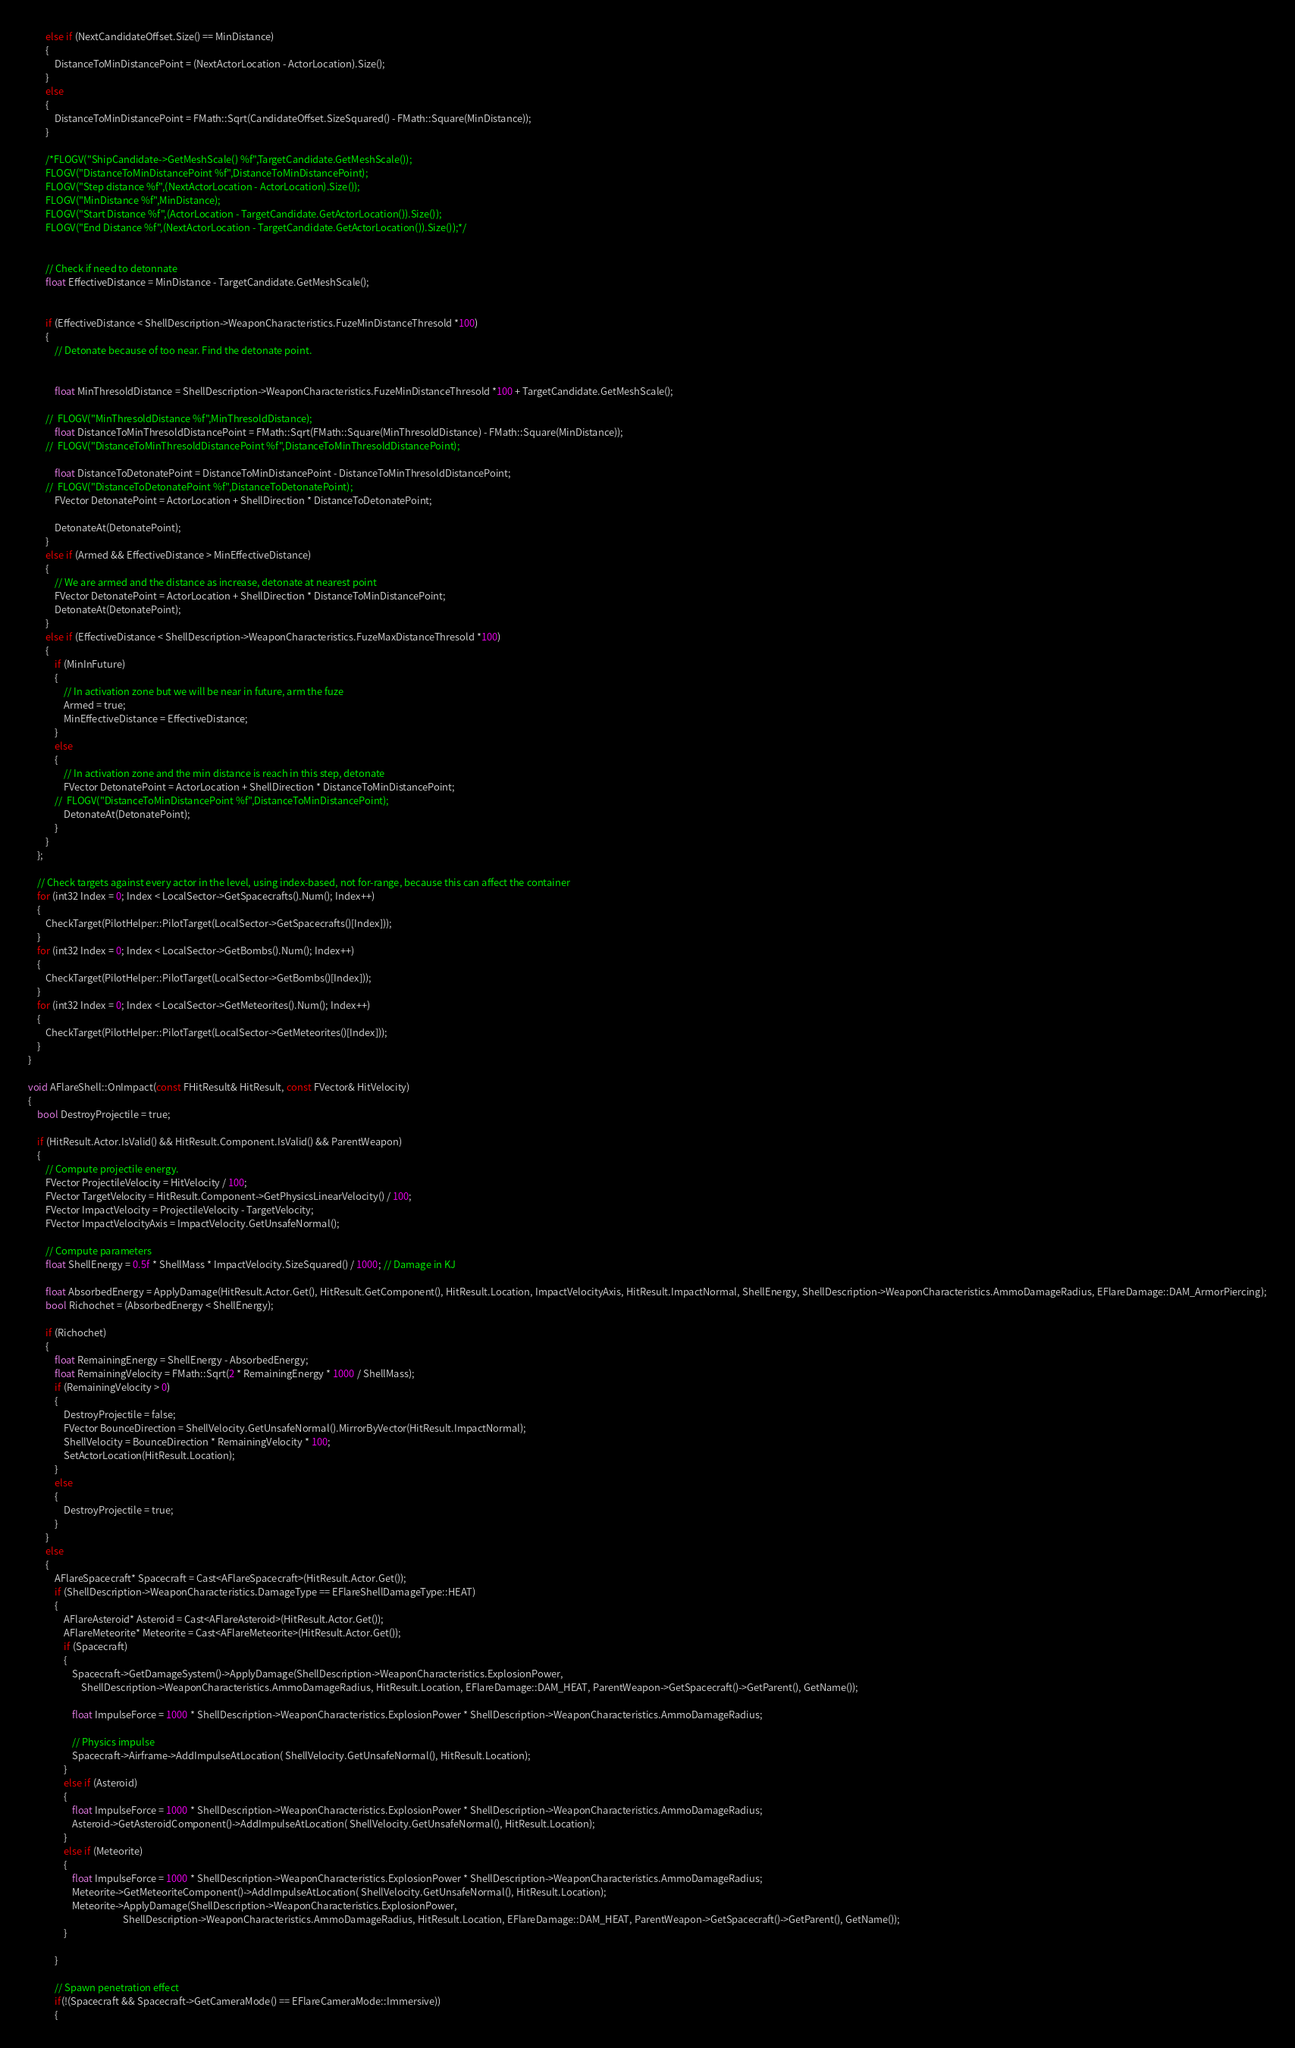Convert code to text. <code><loc_0><loc_0><loc_500><loc_500><_C++_>		else if (NextCandidateOffset.Size() == MinDistance)
		{
			DistanceToMinDistancePoint = (NextActorLocation - ActorLocation).Size();
		}
		else
		{
			DistanceToMinDistancePoint = FMath::Sqrt(CandidateOffset.SizeSquared() - FMath::Square(MinDistance));
		}

		/*FLOGV("ShipCandidate->GetMeshScale() %f",TargetCandidate.GetMeshScale());
		FLOGV("DistanceToMinDistancePoint %f",DistanceToMinDistancePoint);
		FLOGV("Step distance %f",(NextActorLocation - ActorLocation).Size());
		FLOGV("MinDistance %f",MinDistance);
		FLOGV("Start Distance %f",(ActorLocation - TargetCandidate.GetActorLocation()).Size());
		FLOGV("End Distance %f",(NextActorLocation - TargetCandidate.GetActorLocation()).Size());*/


		// Check if need to detonnate
		float EffectiveDistance = MinDistance - TargetCandidate.GetMeshScale();


		if (EffectiveDistance < ShellDescription->WeaponCharacteristics.FuzeMinDistanceThresold *100)
		{
			// Detonate because of too near. Find the detonate point.


			float MinThresoldDistance = ShellDescription->WeaponCharacteristics.FuzeMinDistanceThresold *100 + TargetCandidate.GetMeshScale();

		// 	FLOGV("MinThresoldDistance %f",MinThresoldDistance);
			float DistanceToMinThresoldDistancePoint = FMath::Sqrt(FMath::Square(MinThresoldDistance) - FMath::Square(MinDistance));
		// 	FLOGV("DistanceToMinThresoldDistancePoint %f",DistanceToMinThresoldDistancePoint);

			float DistanceToDetonatePoint = DistanceToMinDistancePoint - DistanceToMinThresoldDistancePoint;
		// 	FLOGV("DistanceToDetonatePoint %f",DistanceToDetonatePoint);
			FVector DetonatePoint = ActorLocation + ShellDirection * DistanceToDetonatePoint;

			DetonateAt(DetonatePoint);
		}
		else if (Armed && EffectiveDistance > MinEffectiveDistance)
		{
			// We are armed and the distance as increase, detonate at nearest point
			FVector DetonatePoint = ActorLocation + ShellDirection * DistanceToMinDistancePoint;
			DetonateAt(DetonatePoint);
		}
		else if (EffectiveDistance < ShellDescription->WeaponCharacteristics.FuzeMaxDistanceThresold *100)
		{
			if (MinInFuture)
			{
				// In activation zone but we will be near in future, arm the fuze
				Armed = true;
				MinEffectiveDistance = EffectiveDistance;
			}
			else
			{
				// In activation zone and the min distance is reach in this step, detonate
				FVector DetonatePoint = ActorLocation + ShellDirection * DistanceToMinDistancePoint;
			// 	FLOGV("DistanceToMinDistancePoint %f",DistanceToMinDistancePoint);
				DetonateAt(DetonatePoint);
			}
		}
	};

	// Check targets against every actor in the level, using index-based, not for-range, because this can affect the container
	for (int32 Index = 0; Index < LocalSector->GetSpacecrafts().Num(); Index++)
	{
		CheckTarget(PilotHelper::PilotTarget(LocalSector->GetSpacecrafts()[Index]));
	}
	for (int32 Index = 0; Index < LocalSector->GetBombs().Num(); Index++)
	{
		CheckTarget(PilotHelper::PilotTarget(LocalSector->GetBombs()[Index]));
	}
	for (int32 Index = 0; Index < LocalSector->GetMeteorites().Num(); Index++)
	{
		CheckTarget(PilotHelper::PilotTarget(LocalSector->GetMeteorites()[Index]));
	}
}

void AFlareShell::OnImpact(const FHitResult& HitResult, const FVector& HitVelocity)
{
	bool DestroyProjectile = true;
	
	if (HitResult.Actor.IsValid() && HitResult.Component.IsValid() && ParentWeapon)
	{
		// Compute projectile energy.
		FVector ProjectileVelocity = HitVelocity / 100;
		FVector TargetVelocity = HitResult.Component->GetPhysicsLinearVelocity() / 100;
		FVector ImpactVelocity = ProjectileVelocity - TargetVelocity;
		FVector ImpactVelocityAxis = ImpactVelocity.GetUnsafeNormal();
	
		// Compute parameters
		float ShellEnergy = 0.5f * ShellMass * ImpactVelocity.SizeSquared() / 1000; // Damage in KJ
		
		float AbsorbedEnergy = ApplyDamage(HitResult.Actor.Get(), HitResult.GetComponent(), HitResult.Location, ImpactVelocityAxis, HitResult.ImpactNormal, ShellEnergy, ShellDescription->WeaponCharacteristics.AmmoDamageRadius, EFlareDamage::DAM_ArmorPiercing);
		bool Richochet = (AbsorbedEnergy < ShellEnergy);

		if (Richochet)
		{
			float RemainingEnergy = ShellEnergy - AbsorbedEnergy;
			float RemainingVelocity = FMath::Sqrt(2 * RemainingEnergy * 1000 / ShellMass);
			if (RemainingVelocity > 0)
			{
				DestroyProjectile = false;
				FVector BounceDirection = ShellVelocity.GetUnsafeNormal().MirrorByVector(HitResult.ImpactNormal);
				ShellVelocity = BounceDirection * RemainingVelocity * 100;
				SetActorLocation(HitResult.Location);
			}
			else
			{
				DestroyProjectile = true;
			}
		}
		else
		{
			AFlareSpacecraft* Spacecraft = Cast<AFlareSpacecraft>(HitResult.Actor.Get());
			if (ShellDescription->WeaponCharacteristics.DamageType == EFlareShellDamageType::HEAT)
			{
				AFlareAsteroid* Asteroid = Cast<AFlareAsteroid>(HitResult.Actor.Get());
				AFlareMeteorite* Meteorite = Cast<AFlareMeteorite>(HitResult.Actor.Get());
				if (Spacecraft)
				{
					Spacecraft->GetDamageSystem()->ApplyDamage(ShellDescription->WeaponCharacteristics.ExplosionPower,
						ShellDescription->WeaponCharacteristics.AmmoDamageRadius, HitResult.Location, EFlareDamage::DAM_HEAT, ParentWeapon->GetSpacecraft()->GetParent(), GetName());

					float ImpulseForce = 1000 * ShellDescription->WeaponCharacteristics.ExplosionPower * ShellDescription->WeaponCharacteristics.AmmoDamageRadius;

					// Physics impulse
					Spacecraft->Airframe->AddImpulseAtLocation( ShellVelocity.GetUnsafeNormal(), HitResult.Location);
				}
				else if (Asteroid)
				{
					float ImpulseForce = 1000 * ShellDescription->WeaponCharacteristics.ExplosionPower * ShellDescription->WeaponCharacteristics.AmmoDamageRadius;
					Asteroid->GetAsteroidComponent()->AddImpulseAtLocation( ShellVelocity.GetUnsafeNormal(), HitResult.Location);
				}
				else if (Meteorite)
				{
					float ImpulseForce = 1000 * ShellDescription->WeaponCharacteristics.ExplosionPower * ShellDescription->WeaponCharacteristics.AmmoDamageRadius;
					Meteorite->GetMeteoriteComponent()->AddImpulseAtLocation( ShellVelocity.GetUnsafeNormal(), HitResult.Location);
					Meteorite->ApplyDamage(ShellDescription->WeaponCharacteristics.ExplosionPower,
										   ShellDescription->WeaponCharacteristics.AmmoDamageRadius, HitResult.Location, EFlareDamage::DAM_HEAT, ParentWeapon->GetSpacecraft()->GetParent(), GetName());
				}

			}

			// Spawn penetration effect
			if(!(Spacecraft && Spacecraft->GetCameraMode() == EFlareCameraMode::Immersive))
			{</code> 